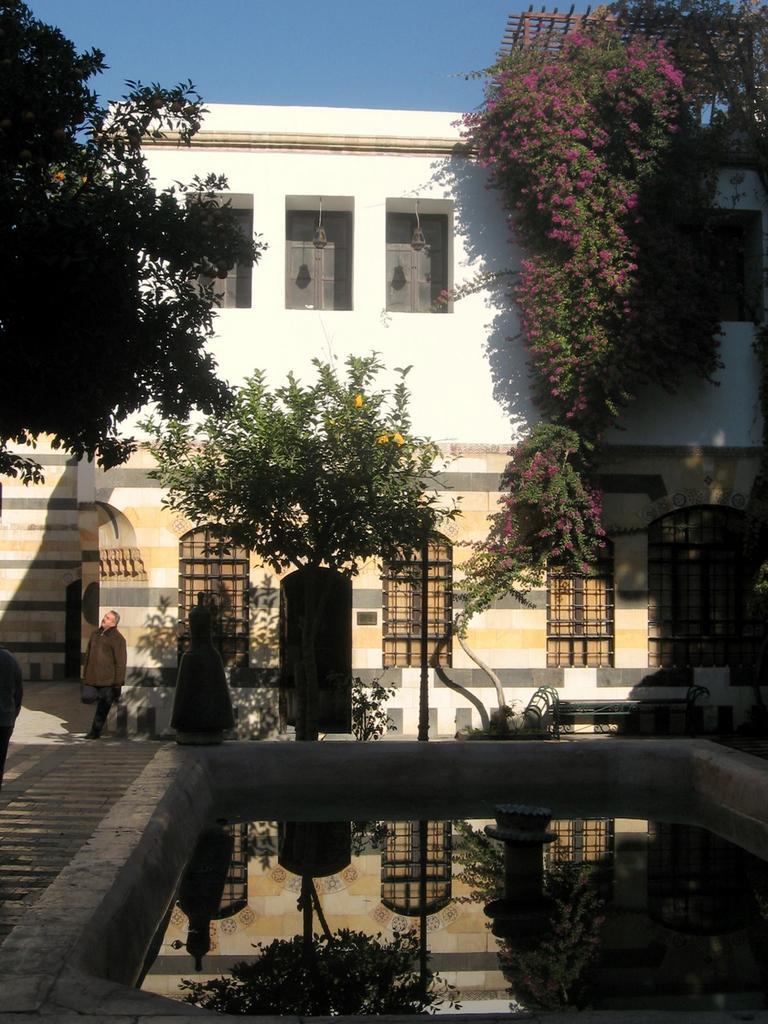How would you summarize this image in a sentence or two? In this image I can see a building in white color. I can also see few trees in green color, a person standing wearing brown jacket and I can see sky in blue color. 